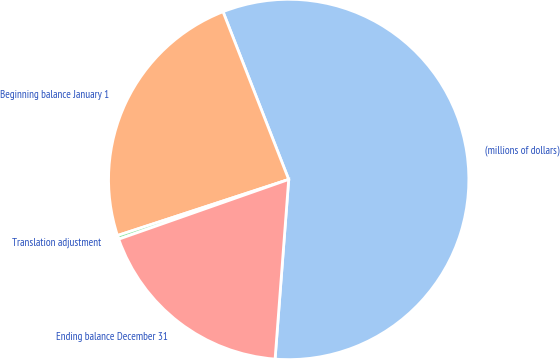Convert chart. <chart><loc_0><loc_0><loc_500><loc_500><pie_chart><fcel>(millions of dollars)<fcel>Beginning balance January 1<fcel>Translation adjustment<fcel>Ending balance December 31<nl><fcel>57.15%<fcel>24.1%<fcel>0.34%<fcel>18.42%<nl></chart> 